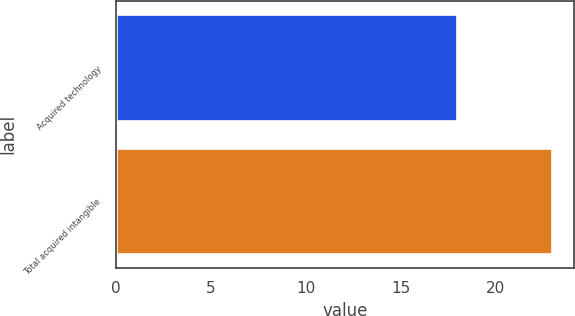Convert chart. <chart><loc_0><loc_0><loc_500><loc_500><bar_chart><fcel>Acquired technology<fcel>Total acquired intangible<nl><fcel>18<fcel>23<nl></chart> 